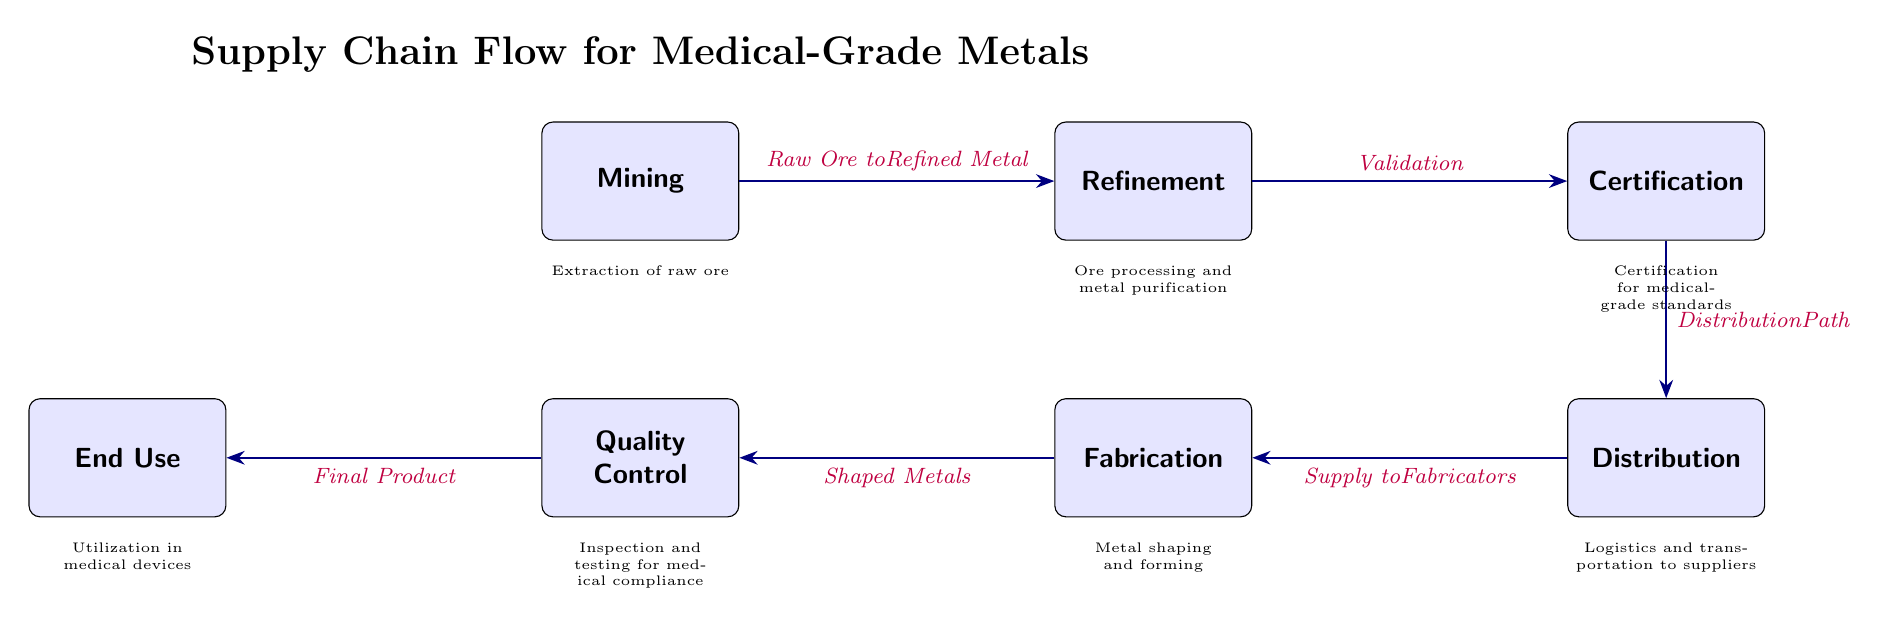What is the first stage in the supply chain? The diagram lists 'Mining' as the first node in the flow of the supply chain process. This indicates that the extraction of raw ore is the initial stage.
Answer: Mining How many total stages are represented in the supply chain? Each node in the diagram represents a stage in the supply chain, and there are seven distinct nodes (stages) noted in the flow: Mining, Refinement, Certification, Distribution, Fabrication, Quality Control, and End Use.
Answer: Seven What process comes after the 'Refinement' stage? The arrow connecting the 'Refinement' node to the 'Certification' node indicates that the next process after refinement is validation and certification of the metal.
Answer: Certification Which stage involves testing for medical compliance? In the flow of the diagram, 'Quality Control' is the stage that focuses on inspection and testing to ensure compliance with medical standards.
Answer: Quality Control What is the end use of the medical-grade metals referred to in the diagram? The flow ultimately leads to 'End Use', indicating how the processed medical-grade metals are utilized in medical devices, specifying the final application of the products.
Answer: Utilization in medical devices What is the typical sequence of supply after 'Certification'? Following the certification stage, the process flows into 'Distribution', where the certified metals are managed in terms of logistics and transportation. This sequence illustrates the order in which metals are distributed to suppliers.
Answer: Distribution What does the edge between 'Fabrication' and 'Quality Control' indicate? The edge between these two nodes indicates that after the shaping and forming of metals, there is a necessary stage of inspection and testing to ensure those shaped metals meet the required standards before final usage.
Answer: Shaped Metals What does the certification ensure in the supply chain? The 'Certification' stage ensures that the metals meet medical-grade standards, validating their quality and safety for use in medical applications, an essential compliance step in the flow.
Answer: Certification for medical-grade standards 